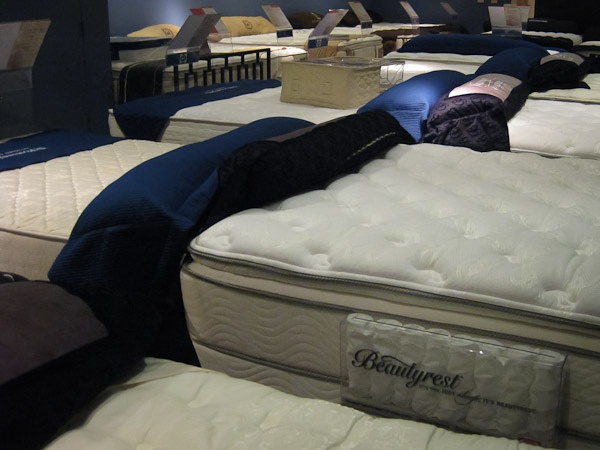Describe the objects in this image and their specific colors. I can see bed in black, darkgray, and gray tones, bed in black, darkgray, and gray tones, bed in black, lightgray, and tan tones, bed in black, lightgray, darkgray, and gray tones, and bed in black, darkgray, and gray tones in this image. 